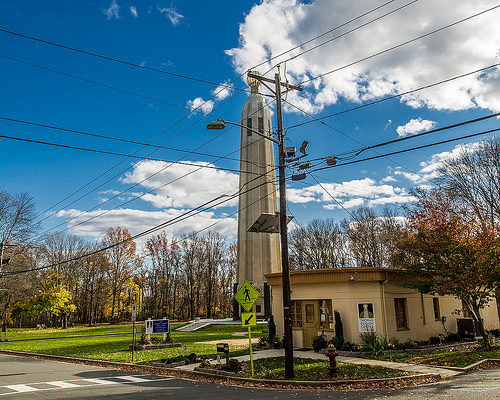<image>
Is the fire hydrant to the right of the building? No. The fire hydrant is not to the right of the building. The horizontal positioning shows a different relationship. 